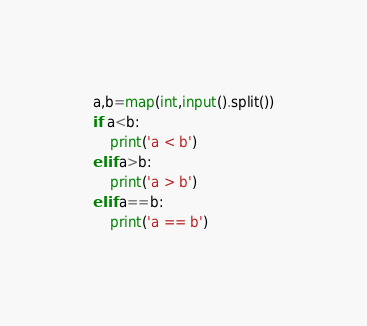Convert code to text. <code><loc_0><loc_0><loc_500><loc_500><_Python_>a,b=map(int,input().split())
if a<b:
    print('a < b')
elif a>b:
    print('a > b')
elif a==b:
    print('a == b')
</code> 